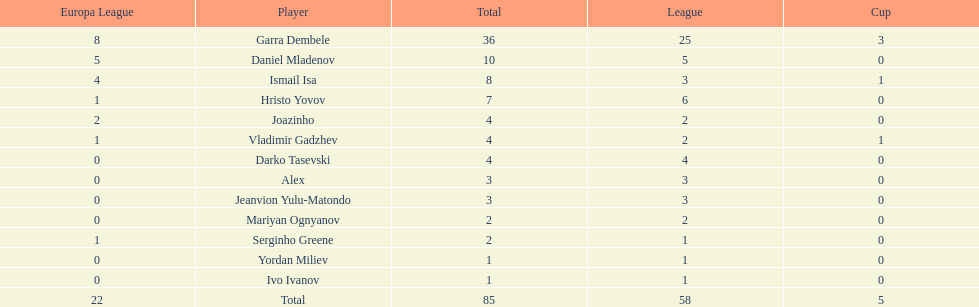Who had the most goal scores? Garra Dembele. 